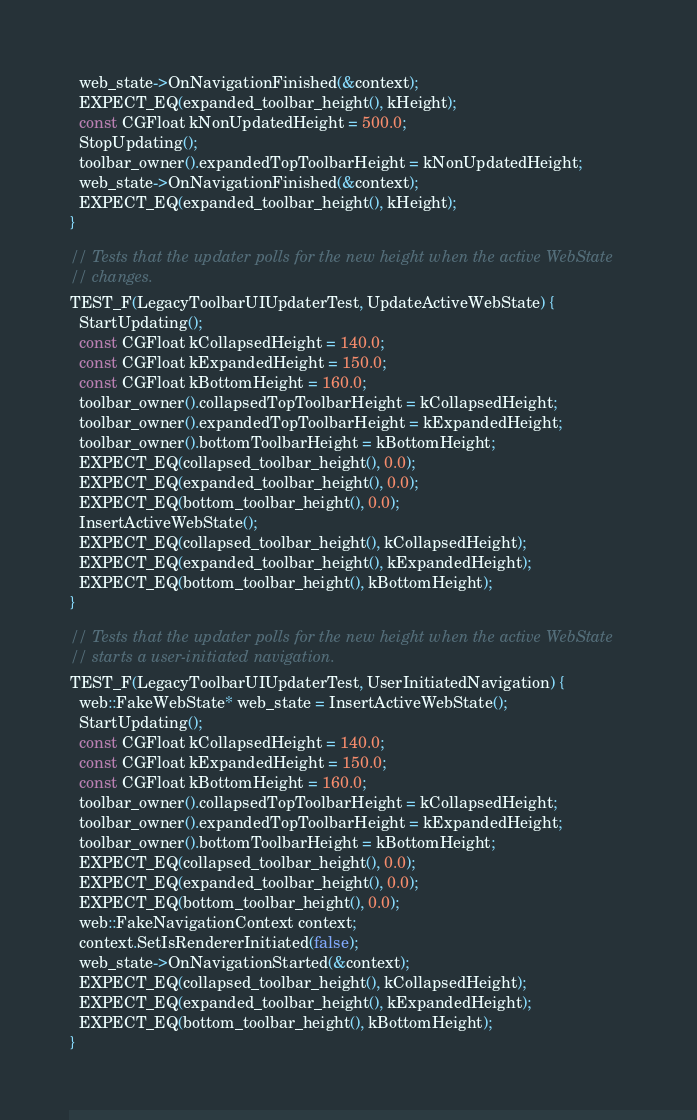<code> <loc_0><loc_0><loc_500><loc_500><_ObjectiveC_>  web_state->OnNavigationFinished(&context);
  EXPECT_EQ(expanded_toolbar_height(), kHeight);
  const CGFloat kNonUpdatedHeight = 500.0;
  StopUpdating();
  toolbar_owner().expandedTopToolbarHeight = kNonUpdatedHeight;
  web_state->OnNavigationFinished(&context);
  EXPECT_EQ(expanded_toolbar_height(), kHeight);
}

// Tests that the updater polls for the new height when the active WebState
// changes.
TEST_F(LegacyToolbarUIUpdaterTest, UpdateActiveWebState) {
  StartUpdating();
  const CGFloat kCollapsedHeight = 140.0;
  const CGFloat kExpandedHeight = 150.0;
  const CGFloat kBottomHeight = 160.0;
  toolbar_owner().collapsedTopToolbarHeight = kCollapsedHeight;
  toolbar_owner().expandedTopToolbarHeight = kExpandedHeight;
  toolbar_owner().bottomToolbarHeight = kBottomHeight;
  EXPECT_EQ(collapsed_toolbar_height(), 0.0);
  EXPECT_EQ(expanded_toolbar_height(), 0.0);
  EXPECT_EQ(bottom_toolbar_height(), 0.0);
  InsertActiveWebState();
  EXPECT_EQ(collapsed_toolbar_height(), kCollapsedHeight);
  EXPECT_EQ(expanded_toolbar_height(), kExpandedHeight);
  EXPECT_EQ(bottom_toolbar_height(), kBottomHeight);
}

// Tests that the updater polls for the new height when the active WebState
// starts a user-initiated navigation.
TEST_F(LegacyToolbarUIUpdaterTest, UserInitiatedNavigation) {
  web::FakeWebState* web_state = InsertActiveWebState();
  StartUpdating();
  const CGFloat kCollapsedHeight = 140.0;
  const CGFloat kExpandedHeight = 150.0;
  const CGFloat kBottomHeight = 160.0;
  toolbar_owner().collapsedTopToolbarHeight = kCollapsedHeight;
  toolbar_owner().expandedTopToolbarHeight = kExpandedHeight;
  toolbar_owner().bottomToolbarHeight = kBottomHeight;
  EXPECT_EQ(collapsed_toolbar_height(), 0.0);
  EXPECT_EQ(expanded_toolbar_height(), 0.0);
  EXPECT_EQ(bottom_toolbar_height(), 0.0);
  web::FakeNavigationContext context;
  context.SetIsRendererInitiated(false);
  web_state->OnNavigationStarted(&context);
  EXPECT_EQ(collapsed_toolbar_height(), kCollapsedHeight);
  EXPECT_EQ(expanded_toolbar_height(), kExpandedHeight);
  EXPECT_EQ(bottom_toolbar_height(), kBottomHeight);
}
</code> 